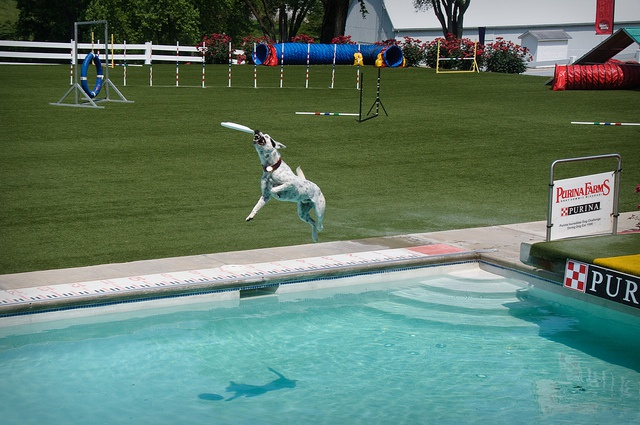Describe the objects in this image and their specific colors. I can see dog in darkgreen, lightgray, teal, and darkgray tones and frisbee in darkgreen, white, and darkgray tones in this image. 